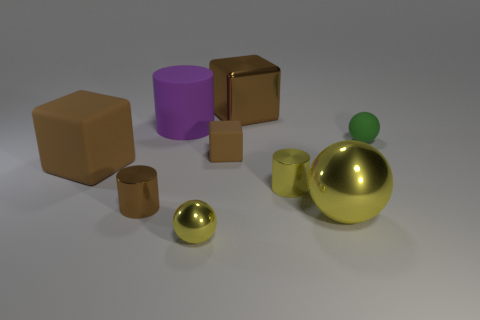Subtract all brown blocks. How many were subtracted if there are1brown blocks left? 2 Subtract all tiny metallic cylinders. How many cylinders are left? 1 Subtract 3 blocks. How many blocks are left? 0 Subtract all yellow spheres. How many spheres are left? 1 Subtract 2 yellow spheres. How many objects are left? 7 Subtract all balls. How many objects are left? 6 Subtract all blue cubes. Subtract all gray cylinders. How many cubes are left? 3 Subtract all green spheres. How many blue cubes are left? 0 Subtract all metal blocks. Subtract all small shiny objects. How many objects are left? 5 Add 6 large metallic blocks. How many large metallic blocks are left? 7 